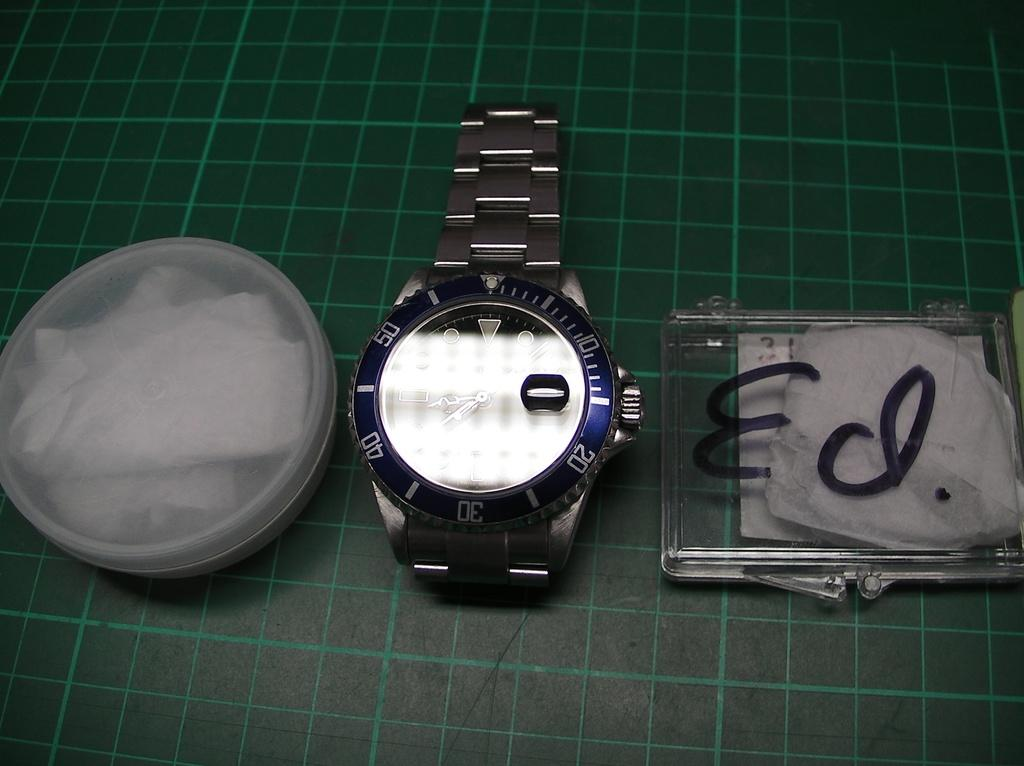<image>
Provide a brief description of the given image. A silver watch sits to the left of a clear box that says Ed. on it. 